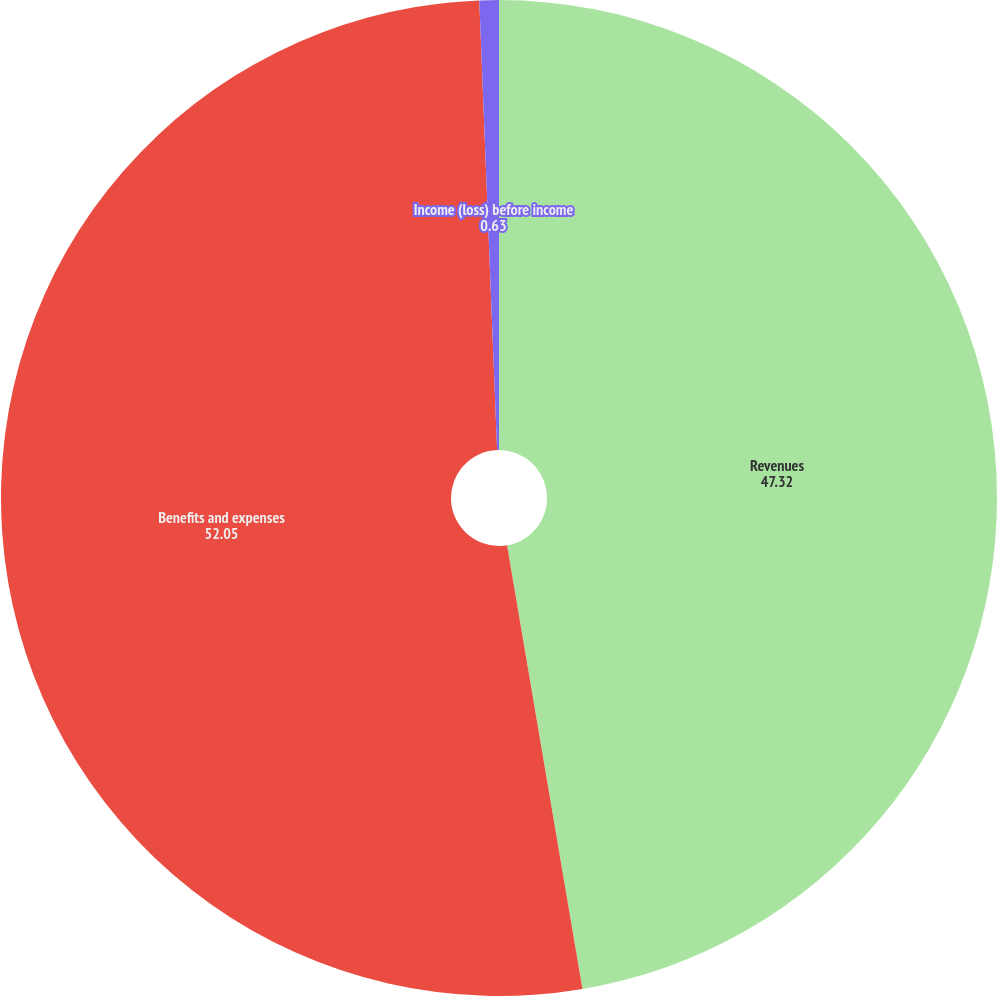Convert chart to OTSL. <chart><loc_0><loc_0><loc_500><loc_500><pie_chart><fcel>Revenues<fcel>Benefits and expenses<fcel>Income (loss) before income<nl><fcel>47.32%<fcel>52.05%<fcel>0.63%<nl></chart> 